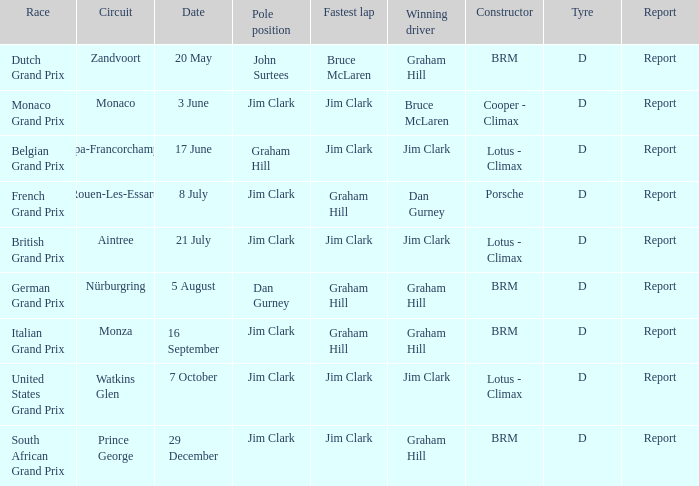What is the date of the circuit of nürburgring, which had Graham Hill as the winning driver? 5 August. 